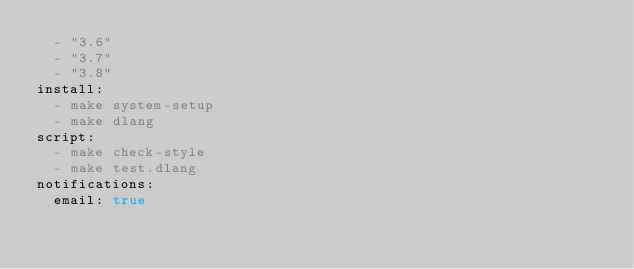Convert code to text. <code><loc_0><loc_0><loc_500><loc_500><_YAML_>  - "3.6"
  - "3.7"
  - "3.8"
install:
  - make system-setup
  - make dlang
script:
  - make check-style
  - make test.dlang
notifications:
  email: true
</code> 